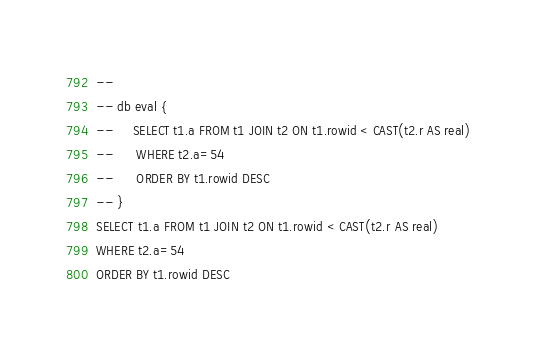<code> <loc_0><loc_0><loc_500><loc_500><_SQL_>-- 
-- db eval {
--     SELECT t1.a FROM t1 JOIN t2 ON t1.rowid < CAST(t2.r AS real)
--      WHERE t2.a=54
--      ORDER BY t1.rowid DESC
-- }
SELECT t1.a FROM t1 JOIN t2 ON t1.rowid < CAST(t2.r AS real)
WHERE t2.a=54
ORDER BY t1.rowid DESC</code> 